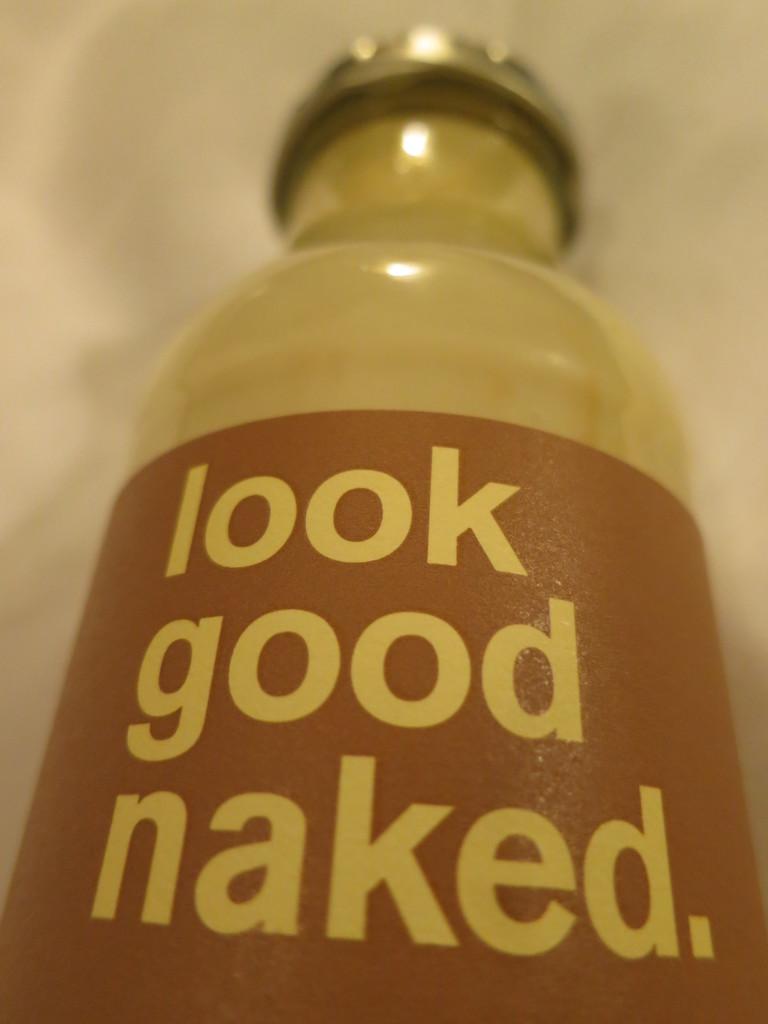What looks naked?
Offer a terse response. Good. 